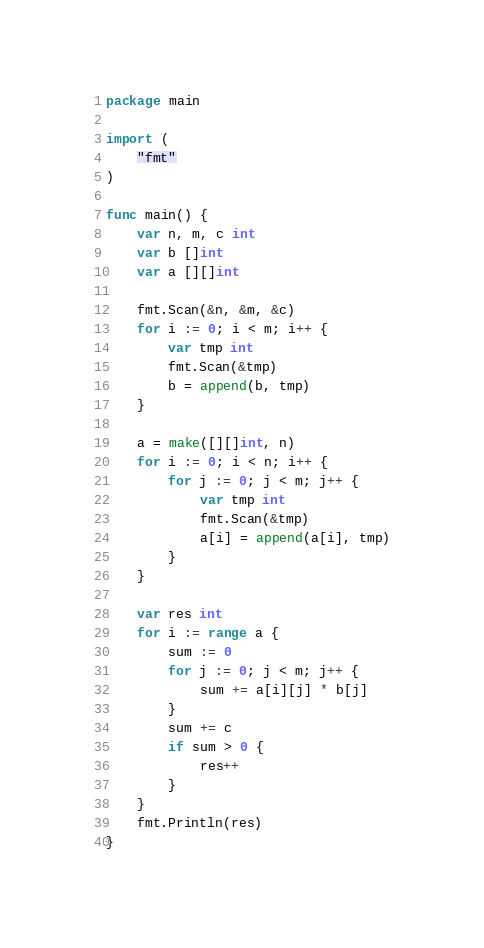<code> <loc_0><loc_0><loc_500><loc_500><_Go_>package main

import (
	"fmt"
)

func main() {
	var n, m, c int
	var b []int
	var a [][]int

	fmt.Scan(&n, &m, &c)
	for i := 0; i < m; i++ {
		var tmp int
		fmt.Scan(&tmp)
		b = append(b, tmp)
	}

	a = make([][]int, n)
	for i := 0; i < n; i++ {
		for j := 0; j < m; j++ {
			var tmp int
			fmt.Scan(&tmp)
			a[i] = append(a[i], tmp)
		}
	}

	var res int
	for i := range a {
		sum := 0
		for j := 0; j < m; j++ {
			sum += a[i][j] * b[j]
		}
		sum += c
		if sum > 0 {
			res++
		}
	}
	fmt.Println(res)
}
</code> 